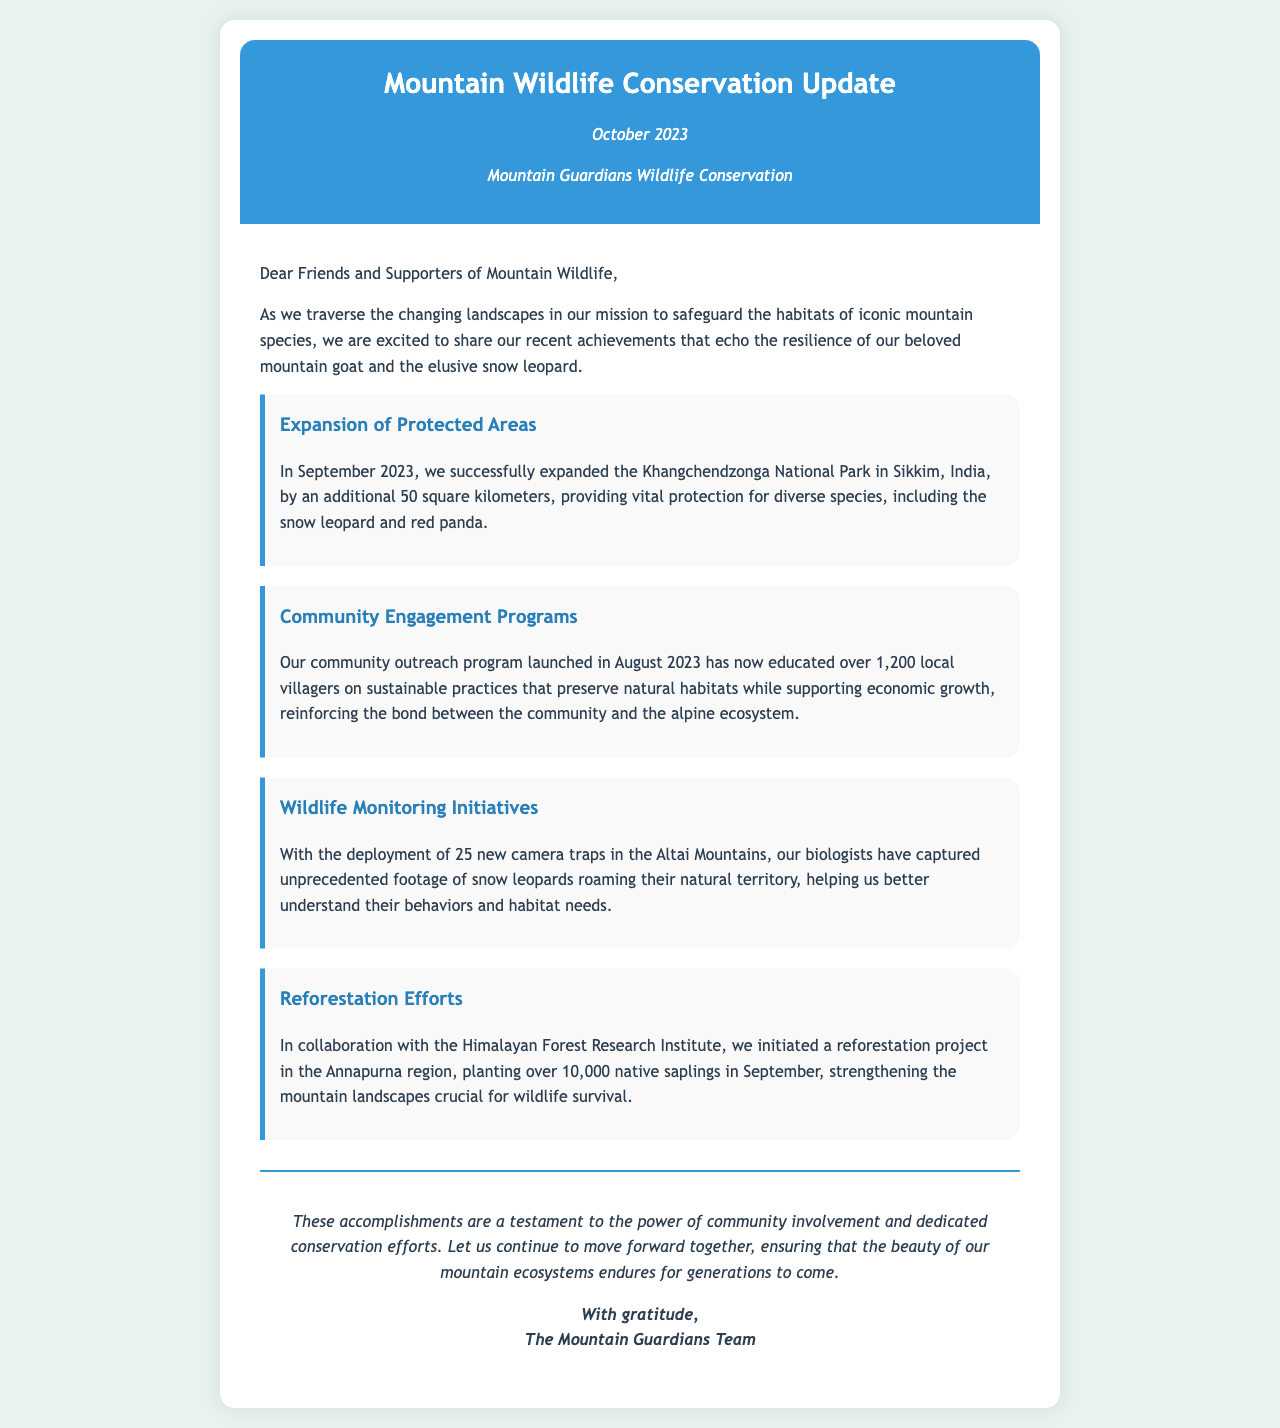What month was the newsletter published? The newsletter is dated October 2023.
Answer: October 2023 How many square kilometers was Khangchendzonga National Park expanded by? The document states that the park was expanded by an additional 50 square kilometers.
Answer: 50 square kilometers How many local villagers were educated through the community outreach program? The document notes that over 1,200 local villagers were educated.
Answer: over 1,200 What ecological initiative began in the Annapurna region? The document mentions a reforestation project initiated in the Annapurna region.
Answer: reforestation project What type of camera traps were deployed in the Altai Mountains? The document specifies that 25 new camera traps were deployed in the Altai Mountains.
Answer: 25 new camera traps What species are highlighted as important in the conservation efforts? The letter mentions the snow leopard and the red panda as important species.
Answer: snow leopard and red panda What is the main theme of the newsletter? The newsletter emphasizes safeguarding the habitats of iconic mountain species.
Answer: safeguarding habitats Who is the letter signed by? The closing signature indicates that it is signed by The Mountain Guardians Team.
Answer: The Mountain Guardians Team 